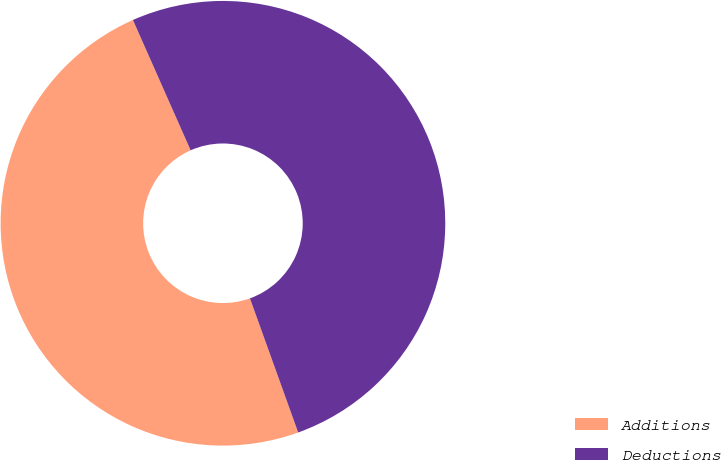Convert chart. <chart><loc_0><loc_0><loc_500><loc_500><pie_chart><fcel>Additions<fcel>Deductions<nl><fcel>48.86%<fcel>51.14%<nl></chart> 